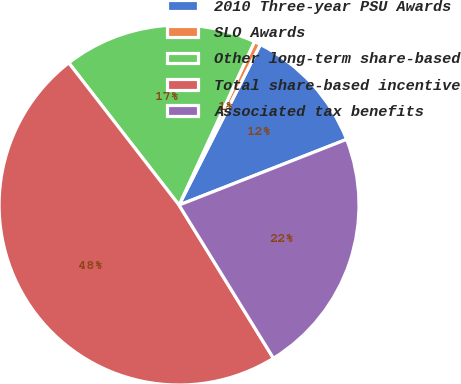Convert chart to OTSL. <chart><loc_0><loc_0><loc_500><loc_500><pie_chart><fcel>2010 Three-year PSU Awards<fcel>SLO Awards<fcel>Other long-term share-based<fcel>Total share-based incentive<fcel>Associated tax benefits<nl><fcel>11.59%<fcel>0.58%<fcel>17.38%<fcel>48.29%<fcel>22.16%<nl></chart> 